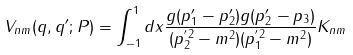Convert formula to latex. <formula><loc_0><loc_0><loc_500><loc_500>V _ { n m } ( q , q ^ { \prime } ; P ) = \int _ { - 1 } ^ { 1 } d x \frac { g ( p _ { 1 } ^ { \prime } - p _ { 2 } ^ { \prime } ) g ( p _ { 2 } ^ { \prime } - p _ { 3 } ) } { ( p ^ { ^ { \prime } 2 } _ { 2 } - m ^ { 2 } ) ( p ^ { ^ { \prime } 2 } _ { 1 } - m ^ { 2 } ) } K _ { n m }</formula> 